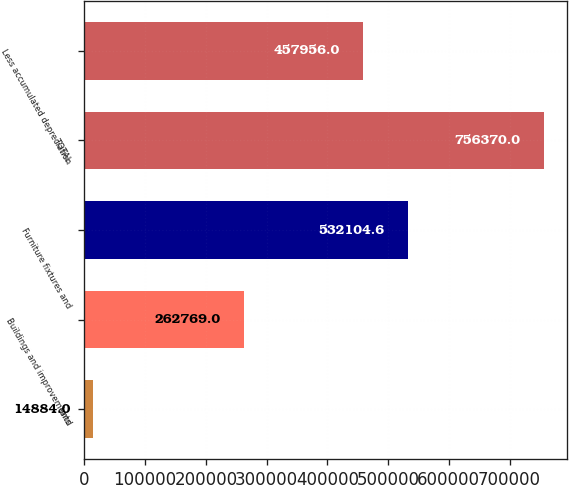Convert chart to OTSL. <chart><loc_0><loc_0><loc_500><loc_500><bar_chart><fcel>Land<fcel>Buildings and improvements<fcel>Furniture fixtures and<fcel>TOTAL<fcel>Less accumulated depreciation<nl><fcel>14884<fcel>262769<fcel>532105<fcel>756370<fcel>457956<nl></chart> 